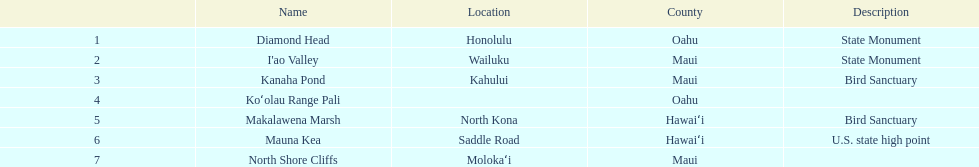In maui, what is the total count of landmarks present? 3. 